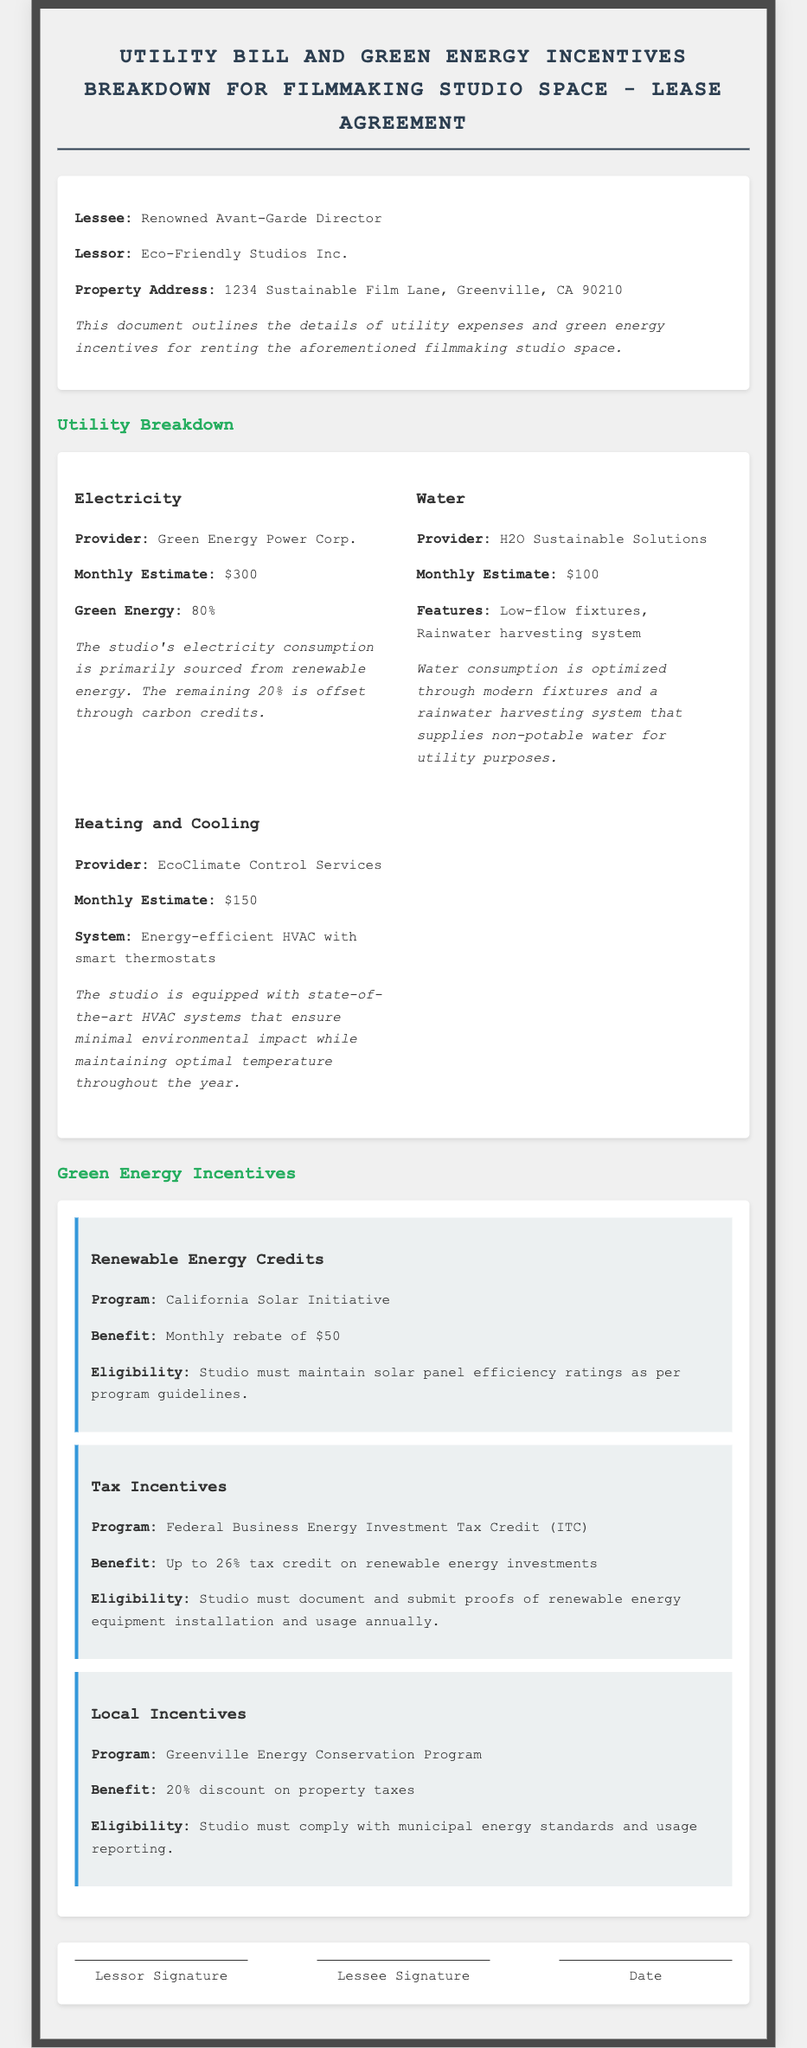What is the monthly estimate for electricity? The monthly estimate for electricity is mentioned in the document, which is $300.
Answer: $300 Who is the provider for water? The document lists H2O Sustainable Solutions as the water provider.
Answer: H2O Sustainable Solutions What is the benefit of the Renewable Energy Credits program? The document states that the benefit is a monthly rebate of $50 under the California Solar Initiative.
Answer: Monthly rebate of $50 What percentage discount do local incentives provide on property taxes? The document specifies that local incentives provide a 20% discount on property taxes.
Answer: 20% What system is used for heating and cooling? The document describes the system as an energy-efficient HVAC with smart thermostats.
Answer: Energy-efficient HVAC with smart thermostats What is the eligibility for the Federal Business Energy Investment Tax Credit? The eligibility requirement includes documenting and submitting proofs of renewable energy equipment installation and usage annually.
Answer: Document and submit proofs annually What is the address of the property? The document states that the property address is 1234 Sustainable Film Lane, Greenville, CA 90210.
Answer: 1234 Sustainable Film Lane, Greenville, CA 90210 What is the provider for heating and cooling? The document identifies EcoClimate Control Services as the provider for heating and cooling.
Answer: EcoClimate Control Services 